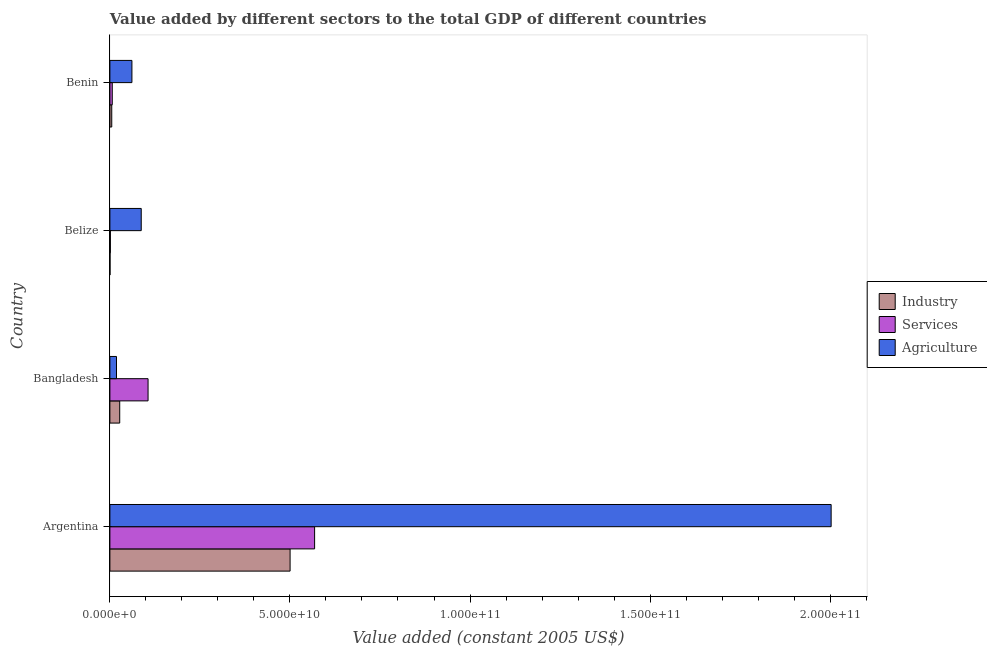How many different coloured bars are there?
Keep it short and to the point. 3. How many groups of bars are there?
Provide a short and direct response. 4. Are the number of bars per tick equal to the number of legend labels?
Offer a terse response. Yes. How many bars are there on the 2nd tick from the top?
Your answer should be very brief. 3. How many bars are there on the 3rd tick from the bottom?
Your response must be concise. 3. What is the label of the 2nd group of bars from the top?
Your answer should be compact. Belize. In how many cases, is the number of bars for a given country not equal to the number of legend labels?
Make the answer very short. 0. What is the value added by services in Argentina?
Ensure brevity in your answer.  5.68e+1. Across all countries, what is the maximum value added by agricultural sector?
Provide a succinct answer. 2.00e+11. Across all countries, what is the minimum value added by services?
Your answer should be compact. 1.34e+08. In which country was the value added by industrial sector minimum?
Your answer should be very brief. Belize. What is the total value added by agricultural sector in the graph?
Keep it short and to the point. 2.17e+11. What is the difference between the value added by agricultural sector in Argentina and that in Bangladesh?
Your answer should be very brief. 1.98e+11. What is the difference between the value added by services in Benin and the value added by agricultural sector in Belize?
Your answer should be compact. -8.05e+09. What is the average value added by agricultural sector per country?
Ensure brevity in your answer.  5.42e+1. What is the difference between the value added by industrial sector and value added by agricultural sector in Argentina?
Give a very brief answer. -1.50e+11. What is the ratio of the value added by agricultural sector in Argentina to that in Bangladesh?
Provide a succinct answer. 109.07. Is the value added by services in Bangladesh less than that in Belize?
Your answer should be very brief. No. Is the difference between the value added by services in Argentina and Bangladesh greater than the difference between the value added by agricultural sector in Argentina and Bangladesh?
Ensure brevity in your answer.  No. What is the difference between the highest and the second highest value added by industrial sector?
Offer a terse response. 4.73e+1. What is the difference between the highest and the lowest value added by services?
Provide a succinct answer. 5.67e+1. In how many countries, is the value added by services greater than the average value added by services taken over all countries?
Offer a terse response. 1. What does the 1st bar from the top in Benin represents?
Ensure brevity in your answer.  Agriculture. What does the 1st bar from the bottom in Benin represents?
Your answer should be very brief. Industry. Is it the case that in every country, the sum of the value added by industrial sector and value added by services is greater than the value added by agricultural sector?
Give a very brief answer. No. How many bars are there?
Offer a very short reply. 12. Are all the bars in the graph horizontal?
Ensure brevity in your answer.  Yes. What is the difference between two consecutive major ticks on the X-axis?
Your response must be concise. 5.00e+1. Where does the legend appear in the graph?
Your answer should be compact. Center right. What is the title of the graph?
Ensure brevity in your answer.  Value added by different sectors to the total GDP of different countries. Does "Taxes" appear as one of the legend labels in the graph?
Give a very brief answer. No. What is the label or title of the X-axis?
Provide a succinct answer. Value added (constant 2005 US$). What is the label or title of the Y-axis?
Ensure brevity in your answer.  Country. What is the Value added (constant 2005 US$) of Industry in Argentina?
Provide a succinct answer. 5.00e+1. What is the Value added (constant 2005 US$) in Services in Argentina?
Your answer should be compact. 5.68e+1. What is the Value added (constant 2005 US$) of Agriculture in Argentina?
Give a very brief answer. 2.00e+11. What is the Value added (constant 2005 US$) of Industry in Bangladesh?
Give a very brief answer. 2.73e+09. What is the Value added (constant 2005 US$) of Services in Bangladesh?
Offer a very short reply. 1.06e+1. What is the Value added (constant 2005 US$) in Agriculture in Bangladesh?
Give a very brief answer. 1.84e+09. What is the Value added (constant 2005 US$) of Industry in Belize?
Your response must be concise. 3.35e+07. What is the Value added (constant 2005 US$) in Services in Belize?
Offer a very short reply. 1.34e+08. What is the Value added (constant 2005 US$) in Agriculture in Belize?
Your answer should be very brief. 8.70e+09. What is the Value added (constant 2005 US$) in Industry in Benin?
Keep it short and to the point. 5.16e+08. What is the Value added (constant 2005 US$) of Services in Benin?
Your answer should be compact. 6.58e+08. What is the Value added (constant 2005 US$) of Agriculture in Benin?
Offer a very short reply. 6.12e+09. Across all countries, what is the maximum Value added (constant 2005 US$) of Industry?
Provide a short and direct response. 5.00e+1. Across all countries, what is the maximum Value added (constant 2005 US$) of Services?
Provide a short and direct response. 5.68e+1. Across all countries, what is the maximum Value added (constant 2005 US$) in Agriculture?
Provide a short and direct response. 2.00e+11. Across all countries, what is the minimum Value added (constant 2005 US$) of Industry?
Provide a short and direct response. 3.35e+07. Across all countries, what is the minimum Value added (constant 2005 US$) of Services?
Offer a terse response. 1.34e+08. Across all countries, what is the minimum Value added (constant 2005 US$) of Agriculture?
Offer a very short reply. 1.84e+09. What is the total Value added (constant 2005 US$) of Industry in the graph?
Provide a succinct answer. 5.33e+1. What is the total Value added (constant 2005 US$) of Services in the graph?
Provide a short and direct response. 6.82e+1. What is the total Value added (constant 2005 US$) of Agriculture in the graph?
Offer a terse response. 2.17e+11. What is the difference between the Value added (constant 2005 US$) of Industry in Argentina and that in Bangladesh?
Your answer should be compact. 4.73e+1. What is the difference between the Value added (constant 2005 US$) of Services in Argentina and that in Bangladesh?
Your response must be concise. 4.62e+1. What is the difference between the Value added (constant 2005 US$) in Agriculture in Argentina and that in Bangladesh?
Offer a terse response. 1.98e+11. What is the difference between the Value added (constant 2005 US$) in Industry in Argentina and that in Belize?
Your answer should be very brief. 5.00e+1. What is the difference between the Value added (constant 2005 US$) of Services in Argentina and that in Belize?
Ensure brevity in your answer.  5.67e+1. What is the difference between the Value added (constant 2005 US$) in Agriculture in Argentina and that in Belize?
Keep it short and to the point. 1.92e+11. What is the difference between the Value added (constant 2005 US$) in Industry in Argentina and that in Benin?
Offer a terse response. 4.95e+1. What is the difference between the Value added (constant 2005 US$) of Services in Argentina and that in Benin?
Your response must be concise. 5.62e+1. What is the difference between the Value added (constant 2005 US$) in Agriculture in Argentina and that in Benin?
Ensure brevity in your answer.  1.94e+11. What is the difference between the Value added (constant 2005 US$) in Industry in Bangladesh and that in Belize?
Ensure brevity in your answer.  2.69e+09. What is the difference between the Value added (constant 2005 US$) of Services in Bangladesh and that in Belize?
Your response must be concise. 1.05e+1. What is the difference between the Value added (constant 2005 US$) in Agriculture in Bangladesh and that in Belize?
Offer a very short reply. -6.87e+09. What is the difference between the Value added (constant 2005 US$) in Industry in Bangladesh and that in Benin?
Keep it short and to the point. 2.21e+09. What is the difference between the Value added (constant 2005 US$) of Services in Bangladesh and that in Benin?
Keep it short and to the point. 9.94e+09. What is the difference between the Value added (constant 2005 US$) of Agriculture in Bangladesh and that in Benin?
Ensure brevity in your answer.  -4.28e+09. What is the difference between the Value added (constant 2005 US$) of Industry in Belize and that in Benin?
Offer a very short reply. -4.83e+08. What is the difference between the Value added (constant 2005 US$) of Services in Belize and that in Benin?
Make the answer very short. -5.25e+08. What is the difference between the Value added (constant 2005 US$) of Agriculture in Belize and that in Benin?
Offer a terse response. 2.58e+09. What is the difference between the Value added (constant 2005 US$) in Industry in Argentina and the Value added (constant 2005 US$) in Services in Bangladesh?
Your answer should be very brief. 3.94e+1. What is the difference between the Value added (constant 2005 US$) in Industry in Argentina and the Value added (constant 2005 US$) in Agriculture in Bangladesh?
Your response must be concise. 4.82e+1. What is the difference between the Value added (constant 2005 US$) in Services in Argentina and the Value added (constant 2005 US$) in Agriculture in Bangladesh?
Keep it short and to the point. 5.50e+1. What is the difference between the Value added (constant 2005 US$) in Industry in Argentina and the Value added (constant 2005 US$) in Services in Belize?
Offer a terse response. 4.99e+1. What is the difference between the Value added (constant 2005 US$) of Industry in Argentina and the Value added (constant 2005 US$) of Agriculture in Belize?
Your answer should be compact. 4.13e+1. What is the difference between the Value added (constant 2005 US$) in Services in Argentina and the Value added (constant 2005 US$) in Agriculture in Belize?
Your answer should be very brief. 4.81e+1. What is the difference between the Value added (constant 2005 US$) in Industry in Argentina and the Value added (constant 2005 US$) in Services in Benin?
Make the answer very short. 4.94e+1. What is the difference between the Value added (constant 2005 US$) of Industry in Argentina and the Value added (constant 2005 US$) of Agriculture in Benin?
Give a very brief answer. 4.39e+1. What is the difference between the Value added (constant 2005 US$) of Services in Argentina and the Value added (constant 2005 US$) of Agriculture in Benin?
Keep it short and to the point. 5.07e+1. What is the difference between the Value added (constant 2005 US$) in Industry in Bangladesh and the Value added (constant 2005 US$) in Services in Belize?
Give a very brief answer. 2.59e+09. What is the difference between the Value added (constant 2005 US$) in Industry in Bangladesh and the Value added (constant 2005 US$) in Agriculture in Belize?
Provide a succinct answer. -5.98e+09. What is the difference between the Value added (constant 2005 US$) in Services in Bangladesh and the Value added (constant 2005 US$) in Agriculture in Belize?
Your response must be concise. 1.89e+09. What is the difference between the Value added (constant 2005 US$) of Industry in Bangladesh and the Value added (constant 2005 US$) of Services in Benin?
Offer a very short reply. 2.07e+09. What is the difference between the Value added (constant 2005 US$) in Industry in Bangladesh and the Value added (constant 2005 US$) in Agriculture in Benin?
Your response must be concise. -3.39e+09. What is the difference between the Value added (constant 2005 US$) of Services in Bangladesh and the Value added (constant 2005 US$) of Agriculture in Benin?
Provide a succinct answer. 4.48e+09. What is the difference between the Value added (constant 2005 US$) in Industry in Belize and the Value added (constant 2005 US$) in Services in Benin?
Offer a very short reply. -6.25e+08. What is the difference between the Value added (constant 2005 US$) in Industry in Belize and the Value added (constant 2005 US$) in Agriculture in Benin?
Keep it short and to the point. -6.09e+09. What is the difference between the Value added (constant 2005 US$) in Services in Belize and the Value added (constant 2005 US$) in Agriculture in Benin?
Your answer should be compact. -5.99e+09. What is the average Value added (constant 2005 US$) in Industry per country?
Provide a succinct answer. 1.33e+1. What is the average Value added (constant 2005 US$) in Services per country?
Provide a succinct answer. 1.71e+1. What is the average Value added (constant 2005 US$) of Agriculture per country?
Your answer should be very brief. 5.42e+1. What is the difference between the Value added (constant 2005 US$) of Industry and Value added (constant 2005 US$) of Services in Argentina?
Make the answer very short. -6.81e+09. What is the difference between the Value added (constant 2005 US$) of Industry and Value added (constant 2005 US$) of Agriculture in Argentina?
Give a very brief answer. -1.50e+11. What is the difference between the Value added (constant 2005 US$) in Services and Value added (constant 2005 US$) in Agriculture in Argentina?
Offer a terse response. -1.43e+11. What is the difference between the Value added (constant 2005 US$) of Industry and Value added (constant 2005 US$) of Services in Bangladesh?
Your answer should be very brief. -7.87e+09. What is the difference between the Value added (constant 2005 US$) of Industry and Value added (constant 2005 US$) of Agriculture in Bangladesh?
Ensure brevity in your answer.  8.92e+08. What is the difference between the Value added (constant 2005 US$) of Services and Value added (constant 2005 US$) of Agriculture in Bangladesh?
Offer a terse response. 8.76e+09. What is the difference between the Value added (constant 2005 US$) of Industry and Value added (constant 2005 US$) of Services in Belize?
Provide a succinct answer. -1.00e+08. What is the difference between the Value added (constant 2005 US$) in Industry and Value added (constant 2005 US$) in Agriculture in Belize?
Provide a succinct answer. -8.67e+09. What is the difference between the Value added (constant 2005 US$) of Services and Value added (constant 2005 US$) of Agriculture in Belize?
Your answer should be very brief. -8.57e+09. What is the difference between the Value added (constant 2005 US$) in Industry and Value added (constant 2005 US$) in Services in Benin?
Ensure brevity in your answer.  -1.42e+08. What is the difference between the Value added (constant 2005 US$) in Industry and Value added (constant 2005 US$) in Agriculture in Benin?
Keep it short and to the point. -5.60e+09. What is the difference between the Value added (constant 2005 US$) in Services and Value added (constant 2005 US$) in Agriculture in Benin?
Provide a succinct answer. -5.46e+09. What is the ratio of the Value added (constant 2005 US$) in Industry in Argentina to that in Bangladesh?
Offer a terse response. 18.34. What is the ratio of the Value added (constant 2005 US$) in Services in Argentina to that in Bangladesh?
Provide a succinct answer. 5.36. What is the ratio of the Value added (constant 2005 US$) in Agriculture in Argentina to that in Bangladesh?
Give a very brief answer. 109.07. What is the ratio of the Value added (constant 2005 US$) of Industry in Argentina to that in Belize?
Offer a terse response. 1495.36. What is the ratio of the Value added (constant 2005 US$) in Services in Argentina to that in Belize?
Keep it short and to the point. 425.71. What is the ratio of the Value added (constant 2005 US$) of Agriculture in Argentina to that in Belize?
Provide a succinct answer. 23.01. What is the ratio of the Value added (constant 2005 US$) in Industry in Argentina to that in Benin?
Offer a terse response. 96.91. What is the ratio of the Value added (constant 2005 US$) in Services in Argentina to that in Benin?
Your answer should be very brief. 86.34. What is the ratio of the Value added (constant 2005 US$) in Agriculture in Argentina to that in Benin?
Your answer should be compact. 32.73. What is the ratio of the Value added (constant 2005 US$) of Industry in Bangladesh to that in Belize?
Your answer should be compact. 81.53. What is the ratio of the Value added (constant 2005 US$) of Services in Bangladesh to that in Belize?
Provide a succinct answer. 79.37. What is the ratio of the Value added (constant 2005 US$) of Agriculture in Bangladesh to that in Belize?
Provide a short and direct response. 0.21. What is the ratio of the Value added (constant 2005 US$) of Industry in Bangladesh to that in Benin?
Ensure brevity in your answer.  5.28. What is the ratio of the Value added (constant 2005 US$) of Services in Bangladesh to that in Benin?
Provide a succinct answer. 16.1. What is the ratio of the Value added (constant 2005 US$) in Agriculture in Bangladesh to that in Benin?
Give a very brief answer. 0.3. What is the ratio of the Value added (constant 2005 US$) of Industry in Belize to that in Benin?
Give a very brief answer. 0.06. What is the ratio of the Value added (constant 2005 US$) of Services in Belize to that in Benin?
Your answer should be compact. 0.2. What is the ratio of the Value added (constant 2005 US$) in Agriculture in Belize to that in Benin?
Provide a succinct answer. 1.42. What is the difference between the highest and the second highest Value added (constant 2005 US$) in Industry?
Your answer should be compact. 4.73e+1. What is the difference between the highest and the second highest Value added (constant 2005 US$) of Services?
Offer a very short reply. 4.62e+1. What is the difference between the highest and the second highest Value added (constant 2005 US$) in Agriculture?
Give a very brief answer. 1.92e+11. What is the difference between the highest and the lowest Value added (constant 2005 US$) of Industry?
Keep it short and to the point. 5.00e+1. What is the difference between the highest and the lowest Value added (constant 2005 US$) of Services?
Your answer should be very brief. 5.67e+1. What is the difference between the highest and the lowest Value added (constant 2005 US$) of Agriculture?
Offer a very short reply. 1.98e+11. 